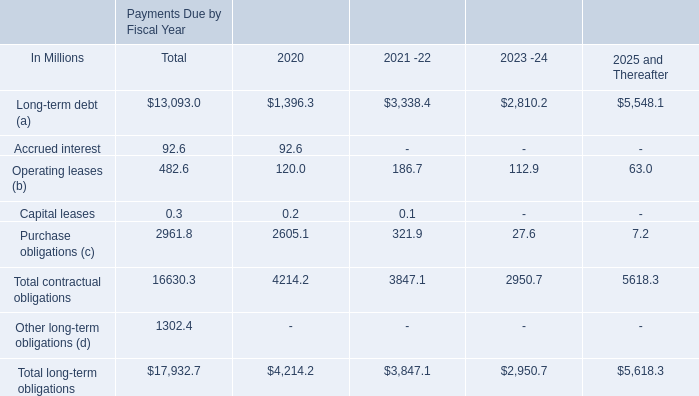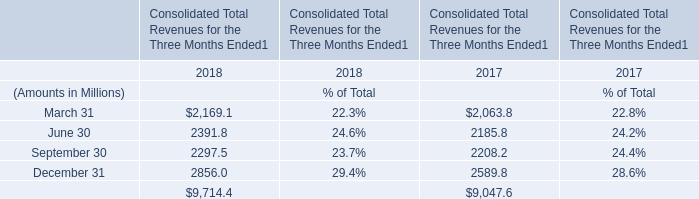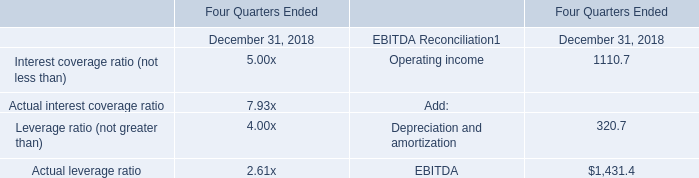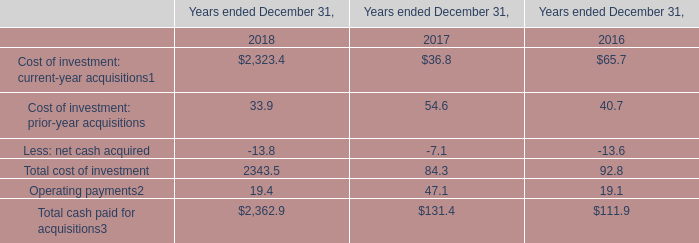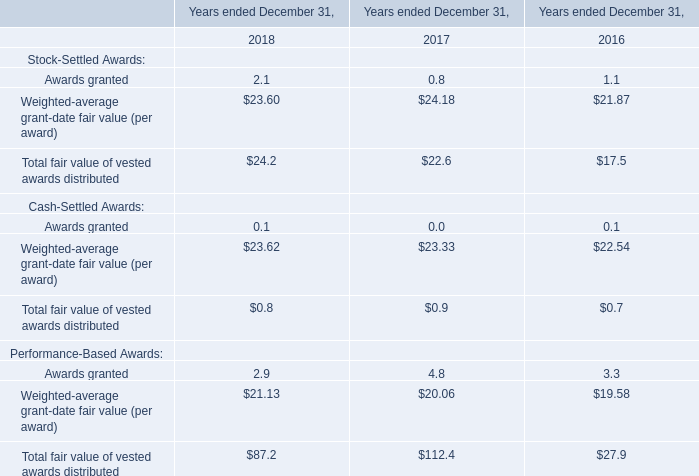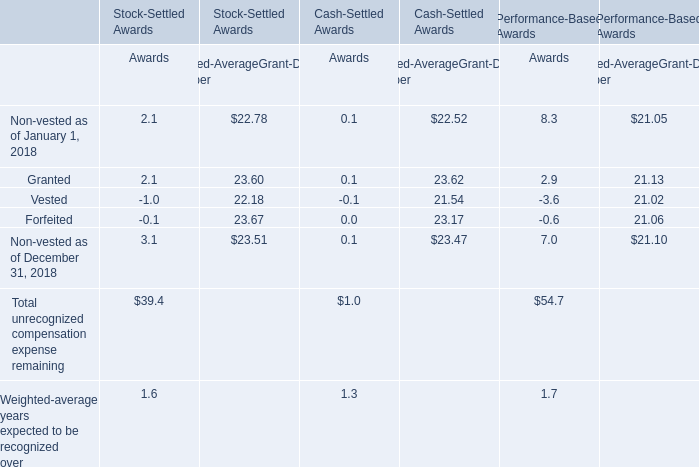Is the total amount of all elements for Stock-Settled Awards greater than that in Performance-Based Awards? 
Answer: no. 